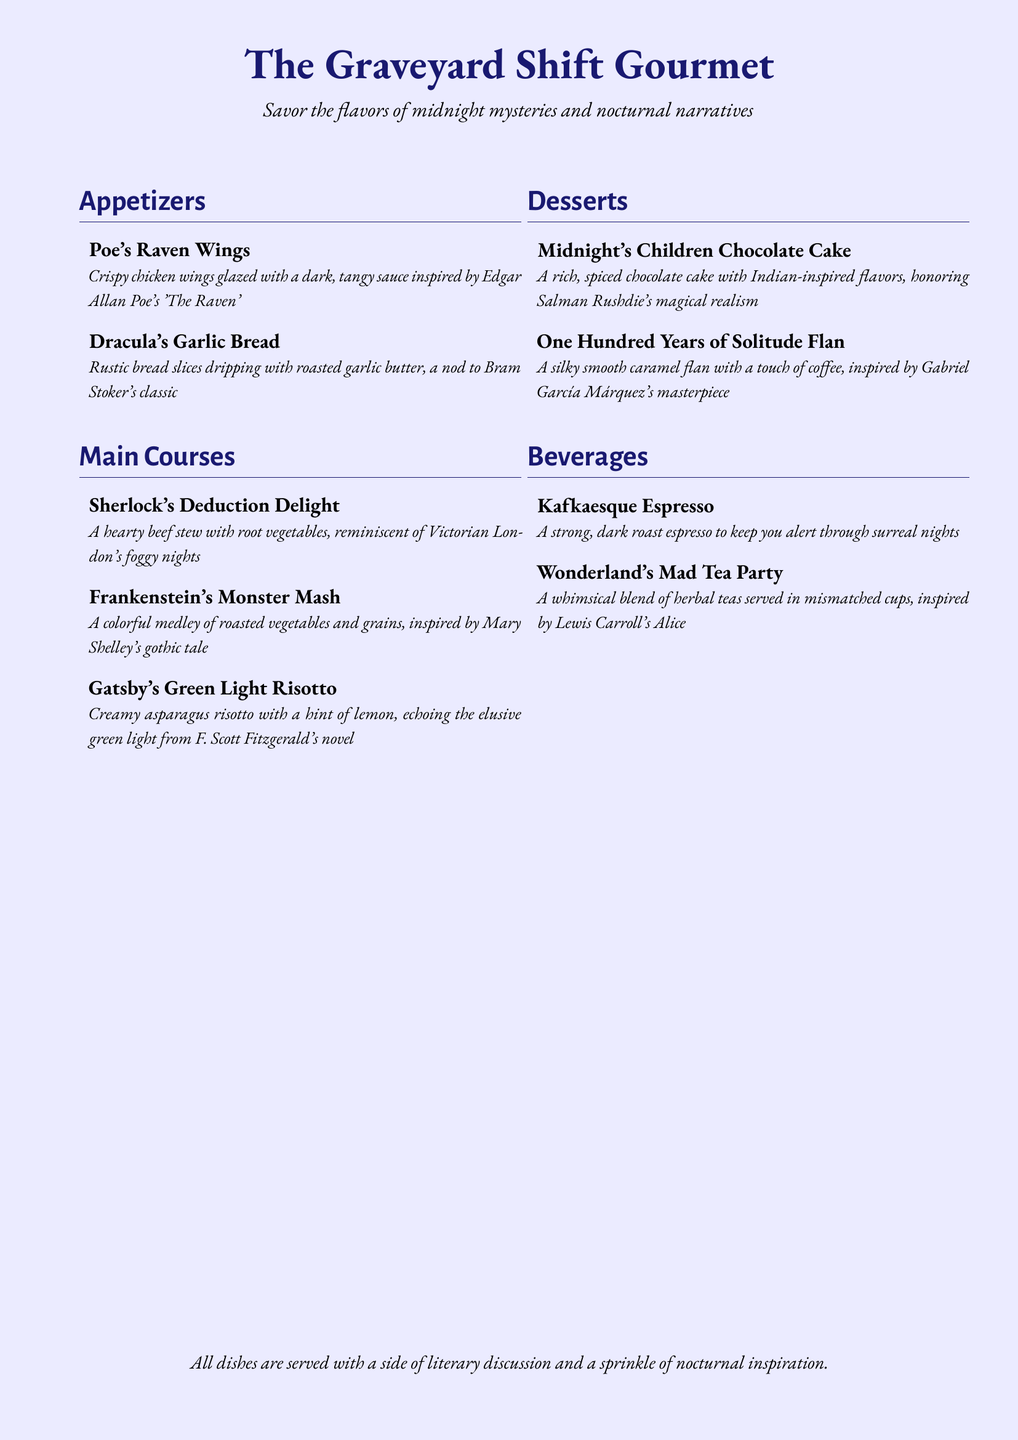What inspired Poe's Raven Wings? The dish is inspired by Edgar Allan Poe's 'The Raven'.
Answer: Edgar Allan Poe's 'The Raven' What type of dish is Gatsby's Green Light Risotto? It is a main course dish in the menu.
Answer: Main course What flavor does the Midnight's Children Chocolate Cake feature? The cake includes Indian-inspired flavors.
Answer: Indian-inspired flavors How many appetizers are listed on the menu? There are two appetizers mentioned in the document.
Answer: Two What is the main vegetable theme of Frankenstein's Monster Mash? The dish features a medley of roasted vegetables and grains.
Answer: Roasted vegetables and grains What beverage is described as strong and dark? Kafkaesque Espresso is described as a strong, dark roast espresso.
Answer: Kafkaesque Espresso Which dish is served with a side of literary discussion? All dishes are served with a side of literary discussion.
Answer: All dishes What is the flavor profile of One Hundred Years of Solitude Flan? It has a smooth caramel flavor with a touch of coffee.
Answer: Smooth caramel with a touch of coffee What is the color theme of the menu background? The background color is described as moonlight.
Answer: Moonlight 